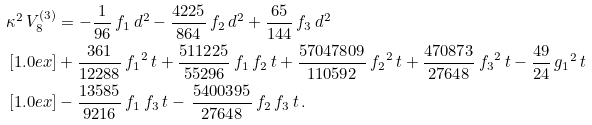<formula> <loc_0><loc_0><loc_500><loc_500>\kappa ^ { 2 } \, V ^ { ( 3 ) } _ { 8 } & = - \frac { 1 } { 9 6 } \, f _ { 1 } \, d ^ { 2 } - \frac { 4 2 2 5 } { 8 6 4 } \, f _ { 2 } \, d ^ { 2 } + \frac { 6 5 } { 1 4 4 } \, { f _ { 3 } } \, d ^ { 2 } \\ [ 1 . 0 e x ] & + \frac { 3 6 1 } { 1 2 2 8 8 } \, { f _ { 1 } } ^ { 2 } \, t + \frac { 5 1 1 2 2 5 } { 5 5 2 9 6 } \, { f _ { 1 } } \, { f _ { 2 } } \, t + \frac { 5 7 0 4 7 8 0 9 } { 1 1 0 5 9 2 } \, { f _ { 2 } } ^ { 2 } \, t + \frac { 4 7 0 8 7 3 } { 2 7 6 4 8 } \, { f _ { 3 } } ^ { 2 } \, t - \frac { 4 9 } { 2 4 } \, { g _ { 1 } } ^ { 2 } \, t \\ [ 1 . 0 e x ] & - \frac { 1 3 5 8 5 } { 9 2 1 6 } \, { f _ { 1 } } \, { f _ { 3 } } \, t - \, \frac { 5 4 0 0 3 9 5 } { 2 7 6 4 8 } \, { f _ { 2 } } \, { f _ { 3 } } \, t \, .</formula> 